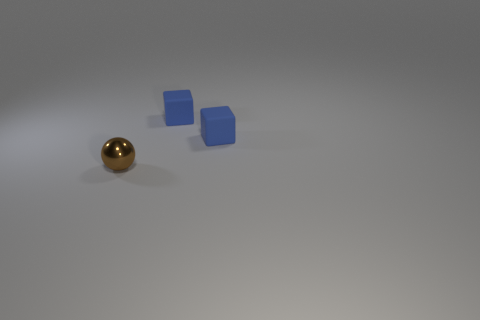Add 3 yellow spheres. How many objects exist? 6 Subtract all blocks. How many objects are left? 1 Subtract 1 cubes. How many cubes are left? 1 Add 2 small brown balls. How many small brown balls are left? 3 Add 2 tiny brown metallic things. How many tiny brown metallic things exist? 3 Subtract 0 green cubes. How many objects are left? 3 Subtract all green cubes. Subtract all blue balls. How many cubes are left? 2 Subtract all cyan balls. How many yellow blocks are left? 0 Subtract all tiny blue rubber blocks. Subtract all brown shiny things. How many objects are left? 0 